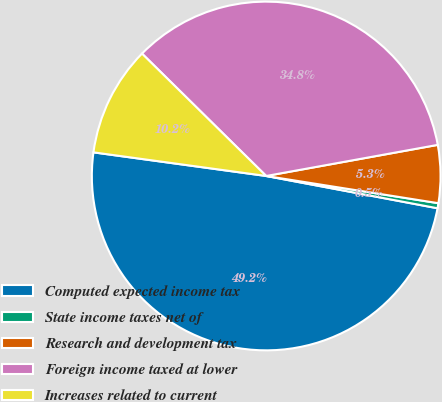Convert chart. <chart><loc_0><loc_0><loc_500><loc_500><pie_chart><fcel>Computed expected income tax<fcel>State income taxes net of<fcel>Research and development tax<fcel>Foreign income taxed at lower<fcel>Increases related to current<nl><fcel>49.2%<fcel>0.47%<fcel>5.35%<fcel>34.76%<fcel>10.22%<nl></chart> 